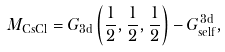Convert formula to latex. <formula><loc_0><loc_0><loc_500><loc_500>M _ { \text {CsCl} } = G _ { \text {3d} } \left ( \frac { 1 } { 2 } , \frac { 1 } { 2 } , \frac { 1 } { 2 } \right ) - G _ { \text {self} } ^ { \text {3d} } ,</formula> 